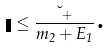Convert formula to latex. <formula><loc_0><loc_0><loc_500><loc_500>\eta \leq \frac { \lambda _ { + } } { m _ { 2 } + E _ { 1 } } \text {.}</formula> 